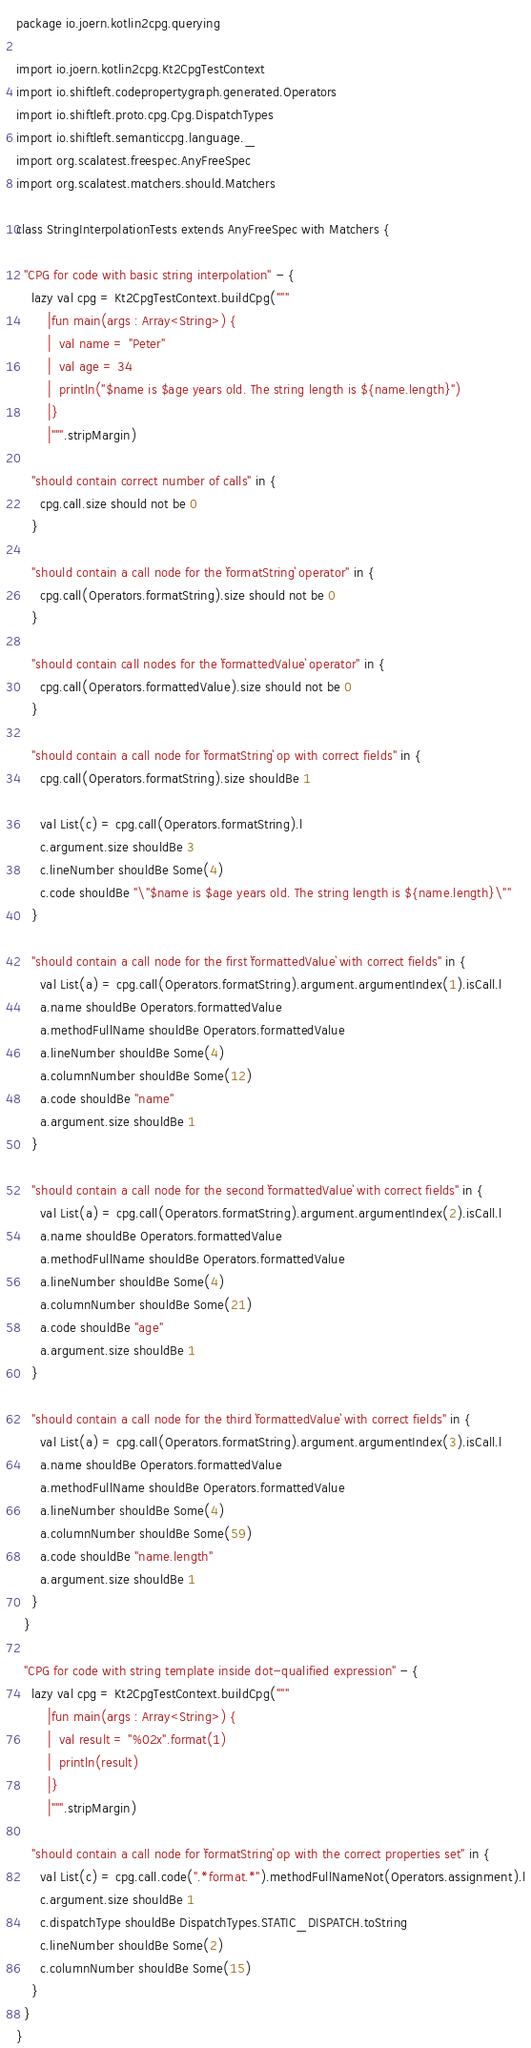<code> <loc_0><loc_0><loc_500><loc_500><_Scala_>package io.joern.kotlin2cpg.querying

import io.joern.kotlin2cpg.Kt2CpgTestContext
import io.shiftleft.codepropertygraph.generated.Operators
import io.shiftleft.proto.cpg.Cpg.DispatchTypes
import io.shiftleft.semanticcpg.language._
import org.scalatest.freespec.AnyFreeSpec
import org.scalatest.matchers.should.Matchers

class StringInterpolationTests extends AnyFreeSpec with Matchers {

  "CPG for code with basic string interpolation" - {
    lazy val cpg = Kt2CpgTestContext.buildCpg("""
        |fun main(args : Array<String>) {
        |  val name = "Peter"
        |  val age = 34
        |  println("$name is $age years old. The string length is ${name.length}")
        |}
        |""".stripMargin)

    "should contain correct number of calls" in {
      cpg.call.size should not be 0
    }

    "should contain a call node for the `formatString` operator" in {
      cpg.call(Operators.formatString).size should not be 0
    }

    "should contain call nodes for the `formattedValue` operator" in {
      cpg.call(Operators.formattedValue).size should not be 0
    }

    "should contain a call node for `formatString` op with correct fields" in {
      cpg.call(Operators.formatString).size shouldBe 1

      val List(c) = cpg.call(Operators.formatString).l
      c.argument.size shouldBe 3
      c.lineNumber shouldBe Some(4)
      c.code shouldBe "\"$name is $age years old. The string length is ${name.length}\""
    }

    "should contain a call node for the first `formattedValue` with correct fields" in {
      val List(a) = cpg.call(Operators.formatString).argument.argumentIndex(1).isCall.l
      a.name shouldBe Operators.formattedValue
      a.methodFullName shouldBe Operators.formattedValue
      a.lineNumber shouldBe Some(4)
      a.columnNumber shouldBe Some(12)
      a.code shouldBe "name"
      a.argument.size shouldBe 1
    }

    "should contain a call node for the second `formattedValue` with correct fields" in {
      val List(a) = cpg.call(Operators.formatString).argument.argumentIndex(2).isCall.l
      a.name shouldBe Operators.formattedValue
      a.methodFullName shouldBe Operators.formattedValue
      a.lineNumber shouldBe Some(4)
      a.columnNumber shouldBe Some(21)
      a.code shouldBe "age"
      a.argument.size shouldBe 1
    }

    "should contain a call node for the third `formattedValue` with correct fields" in {
      val List(a) = cpg.call(Operators.formatString).argument.argumentIndex(3).isCall.l
      a.name shouldBe Operators.formattedValue
      a.methodFullName shouldBe Operators.formattedValue
      a.lineNumber shouldBe Some(4)
      a.columnNumber shouldBe Some(59)
      a.code shouldBe "name.length"
      a.argument.size shouldBe 1
    }
  }

  "CPG for code with string template inside dot-qualified expression" - {
    lazy val cpg = Kt2CpgTestContext.buildCpg("""
        |fun main(args : Array<String>) {
        |  val result = "%02x".format(1)
        |  println(result)
        |}
        |""".stripMargin)

    "should contain a call node for `formatString` op with the correct properties set" in {
      val List(c) = cpg.call.code(".*format.*").methodFullNameNot(Operators.assignment).l
      c.argument.size shouldBe 1
      c.dispatchType shouldBe DispatchTypes.STATIC_DISPATCH.toString
      c.lineNumber shouldBe Some(2)
      c.columnNumber shouldBe Some(15)
    }
  }
}
</code> 